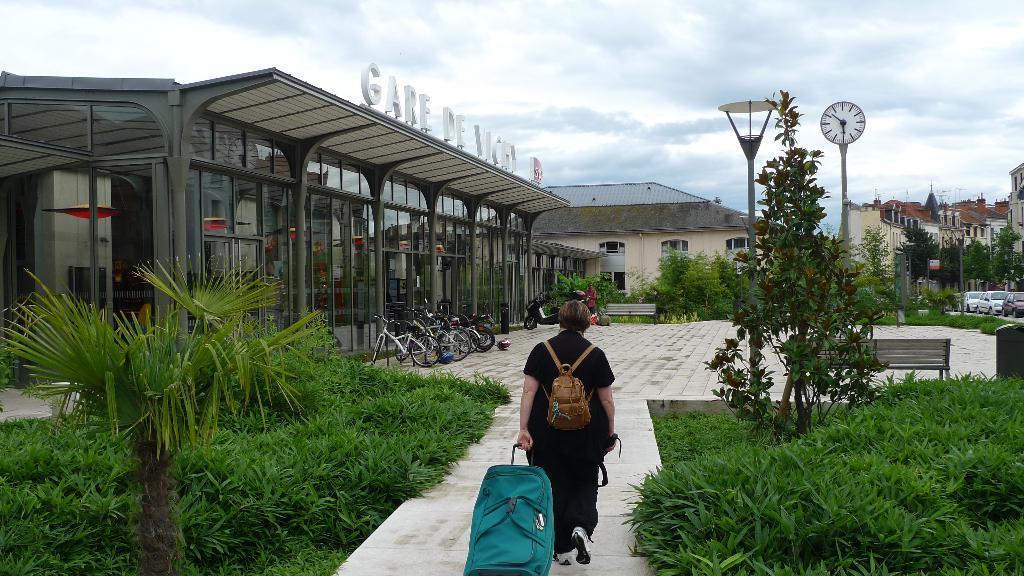Please provide a concise description of this image. In the image we can see a person walking, wearing clothes and carrying a bag on back and the person is holding a luggage bag. We can see even there are building and these are the windows of the building. here we can see grass, plant, clock, bicycle and a cloudy sky. We can even see there are many vehicles. 